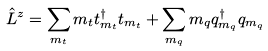<formula> <loc_0><loc_0><loc_500><loc_500>\hat { L } ^ { z } & = \sum _ { m _ { t } } m _ { t } t ^ { \dagger } _ { m _ { t } } t _ { m _ { t } } + \sum _ { m _ { q } } m _ { q } q ^ { \dagger } _ { m _ { q } } q _ { m _ { q } }</formula> 